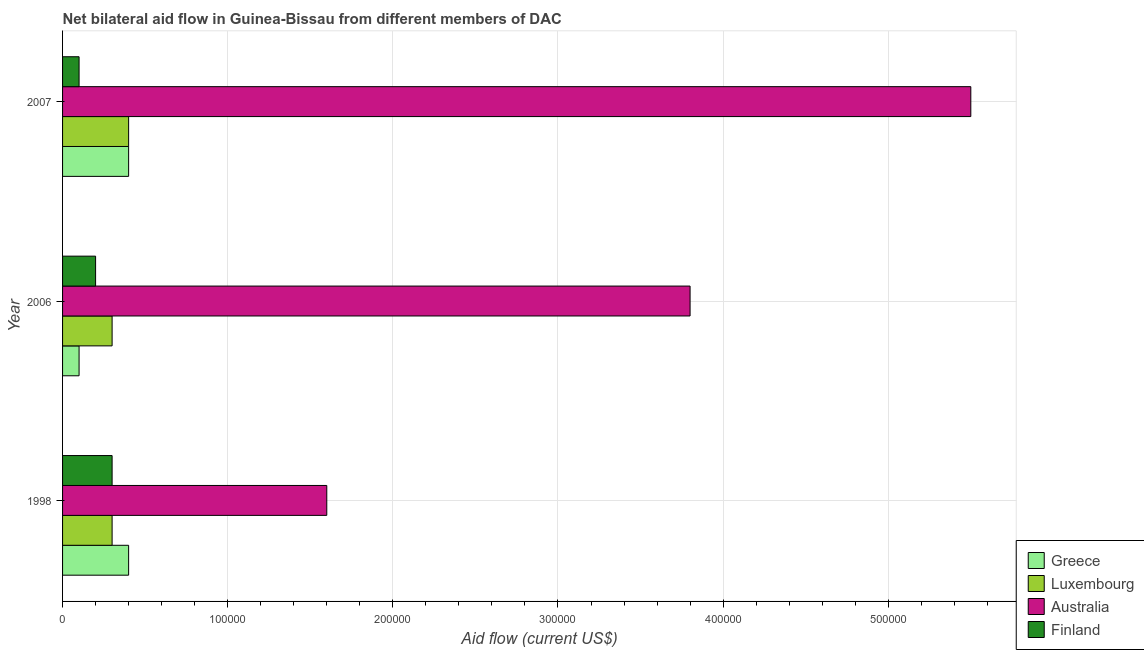How many groups of bars are there?
Your response must be concise. 3. Are the number of bars per tick equal to the number of legend labels?
Provide a short and direct response. Yes. Are the number of bars on each tick of the Y-axis equal?
Keep it short and to the point. Yes. How many bars are there on the 2nd tick from the top?
Give a very brief answer. 4. How many bars are there on the 3rd tick from the bottom?
Ensure brevity in your answer.  4. What is the label of the 1st group of bars from the top?
Provide a short and direct response. 2007. What is the amount of aid given by finland in 2006?
Give a very brief answer. 2.00e+04. Across all years, what is the maximum amount of aid given by luxembourg?
Your answer should be very brief. 4.00e+04. Across all years, what is the minimum amount of aid given by greece?
Keep it short and to the point. 10000. What is the total amount of aid given by luxembourg in the graph?
Provide a short and direct response. 1.00e+05. What is the difference between the amount of aid given by australia in 2006 and that in 2007?
Your answer should be very brief. -1.70e+05. What is the difference between the amount of aid given by australia in 1998 and the amount of aid given by luxembourg in 2007?
Your answer should be compact. 1.20e+05. What is the average amount of aid given by australia per year?
Offer a terse response. 3.63e+05. In the year 2007, what is the difference between the amount of aid given by finland and amount of aid given by luxembourg?
Your response must be concise. -3.00e+04. In how many years, is the amount of aid given by greece greater than 400000 US$?
Make the answer very short. 0. What is the ratio of the amount of aid given by greece in 2006 to that in 2007?
Keep it short and to the point. 0.25. Is the amount of aid given by greece in 1998 less than that in 2007?
Your answer should be very brief. No. What is the difference between the highest and the second highest amount of aid given by australia?
Offer a terse response. 1.70e+05. What is the difference between the highest and the lowest amount of aid given by australia?
Provide a succinct answer. 3.90e+05. Is the sum of the amount of aid given by luxembourg in 1998 and 2006 greater than the maximum amount of aid given by finland across all years?
Give a very brief answer. Yes. What does the 2nd bar from the bottom in 1998 represents?
Make the answer very short. Luxembourg. Are all the bars in the graph horizontal?
Make the answer very short. Yes. What is the difference between two consecutive major ticks on the X-axis?
Make the answer very short. 1.00e+05. How many legend labels are there?
Give a very brief answer. 4. How are the legend labels stacked?
Keep it short and to the point. Vertical. What is the title of the graph?
Make the answer very short. Net bilateral aid flow in Guinea-Bissau from different members of DAC. Does "Services" appear as one of the legend labels in the graph?
Give a very brief answer. No. What is the Aid flow (current US$) of Australia in 1998?
Keep it short and to the point. 1.60e+05. What is the Aid flow (current US$) of Greece in 2006?
Your answer should be compact. 10000. What is the Aid flow (current US$) of Australia in 2006?
Your response must be concise. 3.80e+05. What is the Aid flow (current US$) of Greece in 2007?
Offer a very short reply. 4.00e+04. What is the Aid flow (current US$) in Finland in 2007?
Provide a succinct answer. 10000. Across all years, what is the maximum Aid flow (current US$) in Luxembourg?
Your answer should be very brief. 4.00e+04. Across all years, what is the maximum Aid flow (current US$) in Australia?
Offer a terse response. 5.50e+05. Across all years, what is the minimum Aid flow (current US$) in Greece?
Offer a terse response. 10000. Across all years, what is the minimum Aid flow (current US$) in Australia?
Offer a very short reply. 1.60e+05. What is the total Aid flow (current US$) of Luxembourg in the graph?
Your answer should be compact. 1.00e+05. What is the total Aid flow (current US$) in Australia in the graph?
Give a very brief answer. 1.09e+06. What is the difference between the Aid flow (current US$) of Luxembourg in 1998 and that in 2006?
Give a very brief answer. 0. What is the difference between the Aid flow (current US$) in Luxembourg in 1998 and that in 2007?
Offer a very short reply. -10000. What is the difference between the Aid flow (current US$) in Australia in 1998 and that in 2007?
Give a very brief answer. -3.90e+05. What is the difference between the Aid flow (current US$) of Luxembourg in 2006 and that in 2007?
Your answer should be very brief. -10000. What is the difference between the Aid flow (current US$) in Australia in 2006 and that in 2007?
Provide a short and direct response. -1.70e+05. What is the difference between the Aid flow (current US$) in Greece in 1998 and the Aid flow (current US$) in Luxembourg in 2006?
Offer a very short reply. 10000. What is the difference between the Aid flow (current US$) of Luxembourg in 1998 and the Aid flow (current US$) of Australia in 2006?
Keep it short and to the point. -3.50e+05. What is the difference between the Aid flow (current US$) of Australia in 1998 and the Aid flow (current US$) of Finland in 2006?
Ensure brevity in your answer.  1.40e+05. What is the difference between the Aid flow (current US$) of Greece in 1998 and the Aid flow (current US$) of Luxembourg in 2007?
Ensure brevity in your answer.  0. What is the difference between the Aid flow (current US$) in Greece in 1998 and the Aid flow (current US$) in Australia in 2007?
Your answer should be compact. -5.10e+05. What is the difference between the Aid flow (current US$) of Luxembourg in 1998 and the Aid flow (current US$) of Australia in 2007?
Your answer should be very brief. -5.20e+05. What is the difference between the Aid flow (current US$) of Luxembourg in 1998 and the Aid flow (current US$) of Finland in 2007?
Give a very brief answer. 2.00e+04. What is the difference between the Aid flow (current US$) of Greece in 2006 and the Aid flow (current US$) of Luxembourg in 2007?
Make the answer very short. -3.00e+04. What is the difference between the Aid flow (current US$) of Greece in 2006 and the Aid flow (current US$) of Australia in 2007?
Provide a succinct answer. -5.40e+05. What is the difference between the Aid flow (current US$) in Greece in 2006 and the Aid flow (current US$) in Finland in 2007?
Keep it short and to the point. 0. What is the difference between the Aid flow (current US$) of Luxembourg in 2006 and the Aid flow (current US$) of Australia in 2007?
Ensure brevity in your answer.  -5.20e+05. What is the difference between the Aid flow (current US$) in Luxembourg in 2006 and the Aid flow (current US$) in Finland in 2007?
Offer a very short reply. 2.00e+04. What is the difference between the Aid flow (current US$) of Australia in 2006 and the Aid flow (current US$) of Finland in 2007?
Ensure brevity in your answer.  3.70e+05. What is the average Aid flow (current US$) of Greece per year?
Your response must be concise. 3.00e+04. What is the average Aid flow (current US$) in Luxembourg per year?
Your answer should be very brief. 3.33e+04. What is the average Aid flow (current US$) of Australia per year?
Your answer should be compact. 3.63e+05. In the year 1998, what is the difference between the Aid flow (current US$) of Greece and Aid flow (current US$) of Luxembourg?
Your answer should be compact. 10000. In the year 1998, what is the difference between the Aid flow (current US$) in Greece and Aid flow (current US$) in Finland?
Give a very brief answer. 10000. In the year 1998, what is the difference between the Aid flow (current US$) in Australia and Aid flow (current US$) in Finland?
Your response must be concise. 1.30e+05. In the year 2006, what is the difference between the Aid flow (current US$) of Greece and Aid flow (current US$) of Luxembourg?
Keep it short and to the point. -2.00e+04. In the year 2006, what is the difference between the Aid flow (current US$) of Greece and Aid flow (current US$) of Australia?
Make the answer very short. -3.70e+05. In the year 2006, what is the difference between the Aid flow (current US$) in Greece and Aid flow (current US$) in Finland?
Provide a short and direct response. -10000. In the year 2006, what is the difference between the Aid flow (current US$) in Luxembourg and Aid flow (current US$) in Australia?
Your answer should be very brief. -3.50e+05. In the year 2006, what is the difference between the Aid flow (current US$) in Luxembourg and Aid flow (current US$) in Finland?
Your response must be concise. 10000. In the year 2007, what is the difference between the Aid flow (current US$) in Greece and Aid flow (current US$) in Luxembourg?
Make the answer very short. 0. In the year 2007, what is the difference between the Aid flow (current US$) in Greece and Aid flow (current US$) in Australia?
Your response must be concise. -5.10e+05. In the year 2007, what is the difference between the Aid flow (current US$) of Greece and Aid flow (current US$) of Finland?
Make the answer very short. 3.00e+04. In the year 2007, what is the difference between the Aid flow (current US$) in Luxembourg and Aid flow (current US$) in Australia?
Give a very brief answer. -5.10e+05. In the year 2007, what is the difference between the Aid flow (current US$) in Australia and Aid flow (current US$) in Finland?
Keep it short and to the point. 5.40e+05. What is the ratio of the Aid flow (current US$) of Luxembourg in 1998 to that in 2006?
Provide a short and direct response. 1. What is the ratio of the Aid flow (current US$) in Australia in 1998 to that in 2006?
Provide a succinct answer. 0.42. What is the ratio of the Aid flow (current US$) of Luxembourg in 1998 to that in 2007?
Give a very brief answer. 0.75. What is the ratio of the Aid flow (current US$) of Australia in 1998 to that in 2007?
Offer a very short reply. 0.29. What is the ratio of the Aid flow (current US$) of Greece in 2006 to that in 2007?
Keep it short and to the point. 0.25. What is the ratio of the Aid flow (current US$) of Australia in 2006 to that in 2007?
Offer a very short reply. 0.69. What is the ratio of the Aid flow (current US$) in Finland in 2006 to that in 2007?
Provide a succinct answer. 2. What is the difference between the highest and the second highest Aid flow (current US$) of Luxembourg?
Give a very brief answer. 10000. What is the difference between the highest and the second highest Aid flow (current US$) of Finland?
Provide a short and direct response. 10000. What is the difference between the highest and the lowest Aid flow (current US$) in Luxembourg?
Your answer should be very brief. 10000. What is the difference between the highest and the lowest Aid flow (current US$) in Finland?
Ensure brevity in your answer.  2.00e+04. 